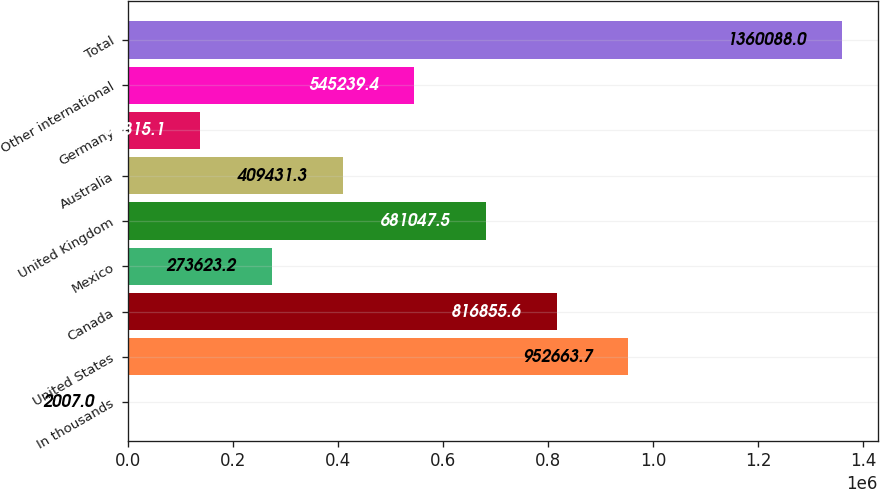Convert chart to OTSL. <chart><loc_0><loc_0><loc_500><loc_500><bar_chart><fcel>In thousands<fcel>United States<fcel>Canada<fcel>Mexico<fcel>United Kingdom<fcel>Australia<fcel>Germany<fcel>Other international<fcel>Total<nl><fcel>2007<fcel>952664<fcel>816856<fcel>273623<fcel>681048<fcel>409431<fcel>137815<fcel>545239<fcel>1.36009e+06<nl></chart> 